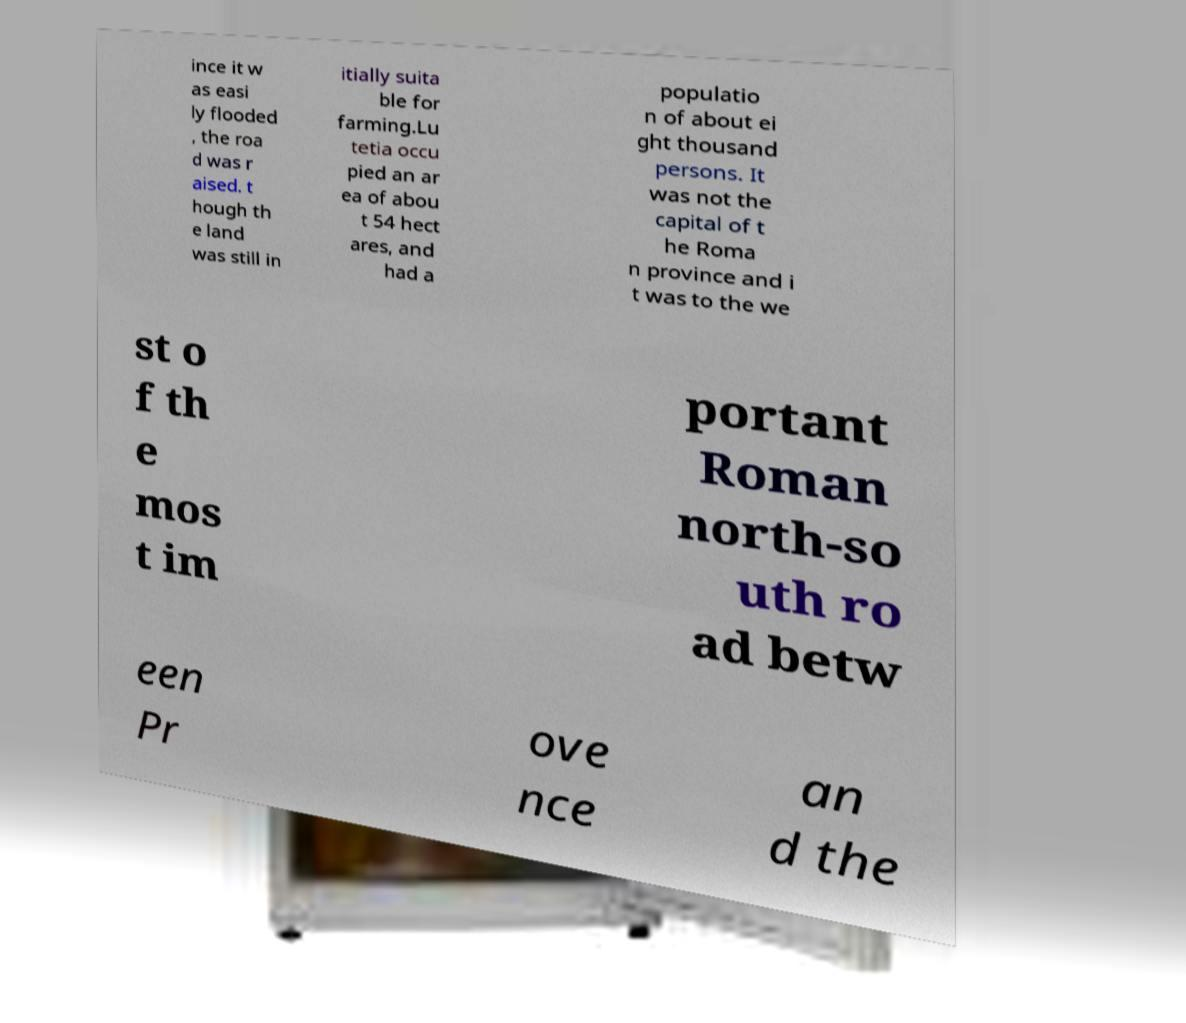Can you accurately transcribe the text from the provided image for me? ince it w as easi ly flooded , the roa d was r aised. t hough th e land was still in itially suita ble for farming.Lu tetia occu pied an ar ea of abou t 54 hect ares, and had a populatio n of about ei ght thousand persons. It was not the capital of t he Roma n province and i t was to the we st o f th e mos t im portant Roman north-so uth ro ad betw een Pr ove nce an d the 